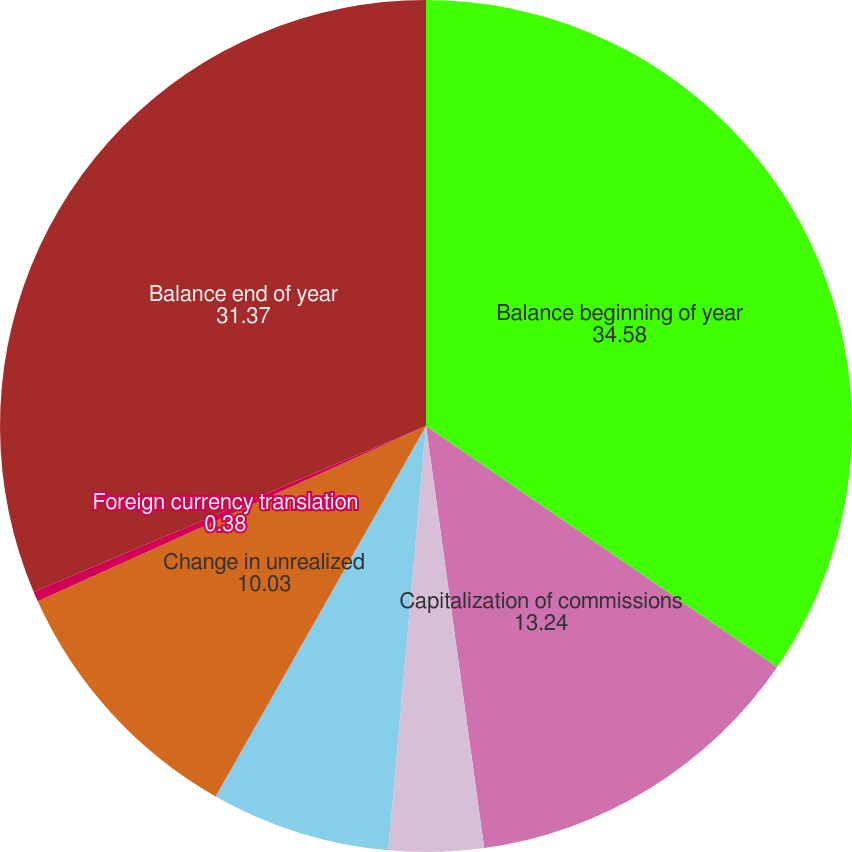Convert chart to OTSL. <chart><loc_0><loc_0><loc_500><loc_500><pie_chart><fcel>Balance beginning of year<fcel>Capitalization of commissions<fcel>Amortization-Impact of<fcel>Amortization-All Other<fcel>Change in unrealized<fcel>Foreign currency translation<fcel>Balance end of year<nl><fcel>34.58%<fcel>13.24%<fcel>3.59%<fcel>6.81%<fcel>10.03%<fcel>0.38%<fcel>31.37%<nl></chart> 